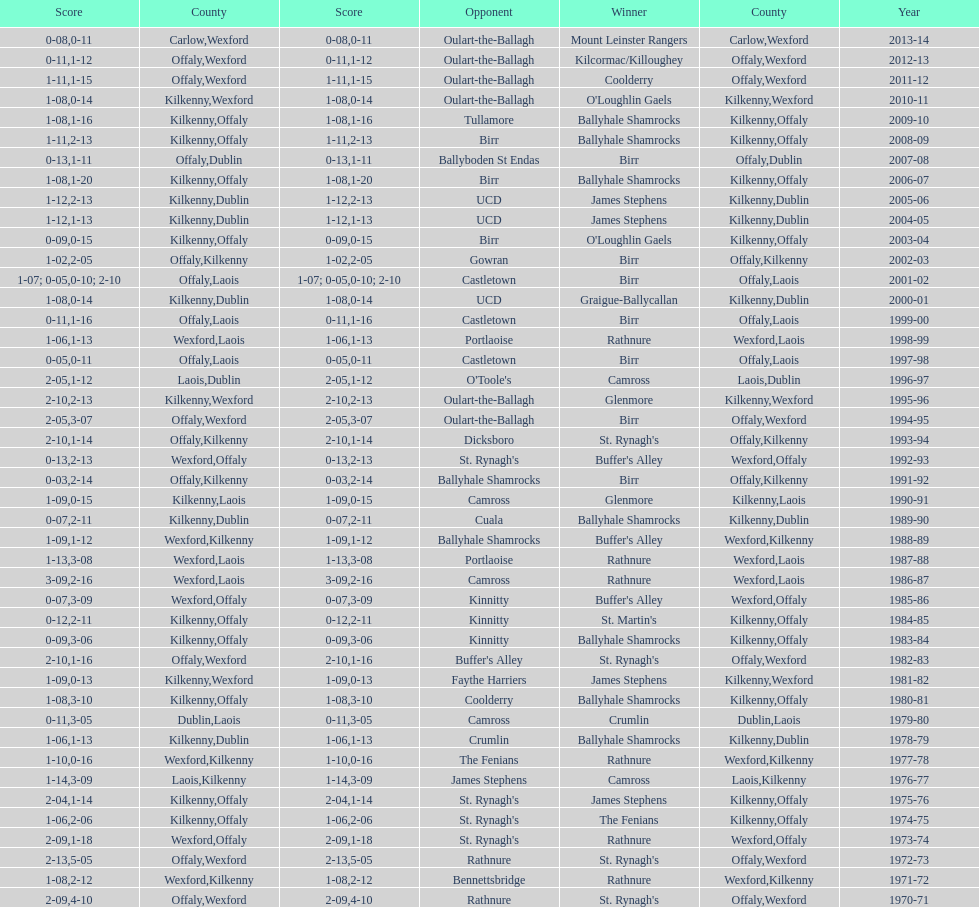How many consecutive years did rathnure win? 2. 